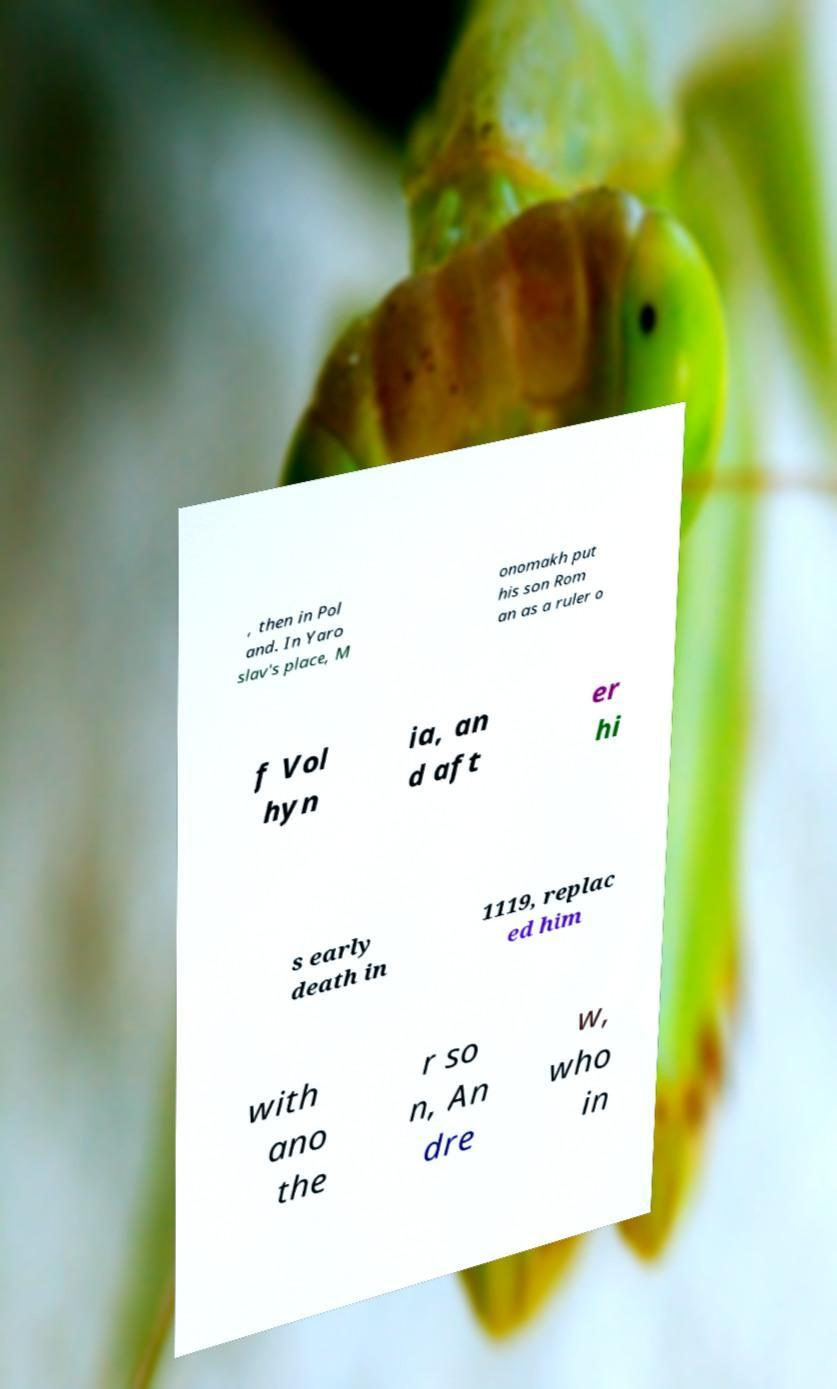I need the written content from this picture converted into text. Can you do that? , then in Pol and. In Yaro slav's place, M onomakh put his son Rom an as a ruler o f Vol hyn ia, an d aft er hi s early death in 1119, replac ed him with ano the r so n, An dre w, who in 